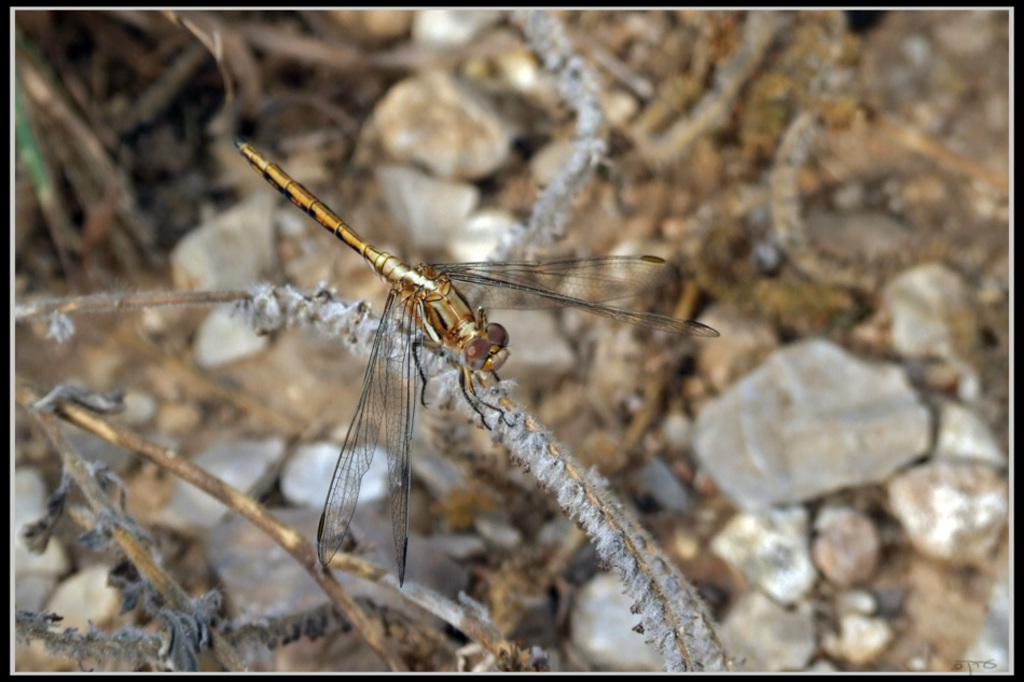What insect is present in the image? There is a dragonfly in the image. Where is the dragonfly located? The dragonfly is on a stem in the image. What else can be seen on the stem? There are stems visible in the image. How would you describe the background of the image? The background of the image is blurry. What type of natural elements can be seen in the background? There are stones visible in the background of the image. What type of meat is hanging from the wire in the image? There is no wire or meat present in the image; it features a dragonfly on a stem with a blurry background. 